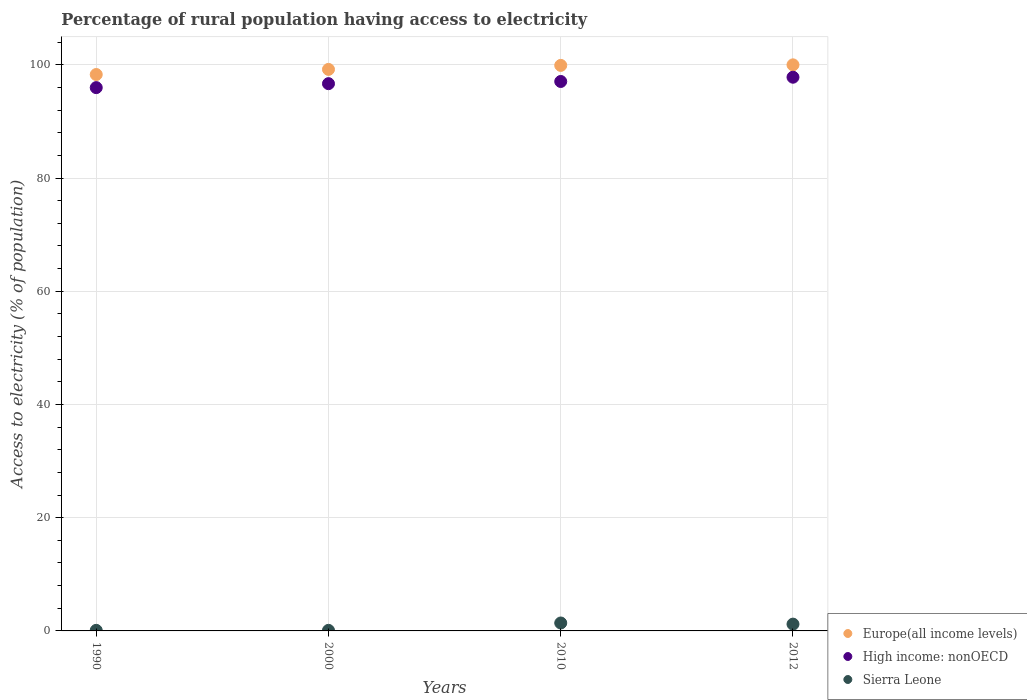How many different coloured dotlines are there?
Give a very brief answer. 3. Is the number of dotlines equal to the number of legend labels?
Make the answer very short. Yes. What is the percentage of rural population having access to electricity in Sierra Leone in 2000?
Provide a succinct answer. 0.1. Across all years, what is the maximum percentage of rural population having access to electricity in Europe(all income levels)?
Your answer should be very brief. 100. Across all years, what is the minimum percentage of rural population having access to electricity in Sierra Leone?
Give a very brief answer. 0.1. In which year was the percentage of rural population having access to electricity in High income: nonOECD maximum?
Offer a very short reply. 2012. What is the total percentage of rural population having access to electricity in Sierra Leone in the graph?
Provide a succinct answer. 2.8. What is the difference between the percentage of rural population having access to electricity in High income: nonOECD in 1990 and that in 2012?
Your response must be concise. -1.84. What is the difference between the percentage of rural population having access to electricity in High income: nonOECD in 1990 and the percentage of rural population having access to electricity in Europe(all income levels) in 2012?
Ensure brevity in your answer.  -4.02. What is the average percentage of rural population having access to electricity in Sierra Leone per year?
Offer a very short reply. 0.7. In the year 1990, what is the difference between the percentage of rural population having access to electricity in Sierra Leone and percentage of rural population having access to electricity in High income: nonOECD?
Your response must be concise. -95.88. What is the ratio of the percentage of rural population having access to electricity in High income: nonOECD in 2000 to that in 2010?
Ensure brevity in your answer.  1. Is the percentage of rural population having access to electricity in High income: nonOECD in 2000 less than that in 2010?
Keep it short and to the point. Yes. What is the difference between the highest and the second highest percentage of rural population having access to electricity in Sierra Leone?
Your response must be concise. 0.2. What is the difference between the highest and the lowest percentage of rural population having access to electricity in Europe(all income levels)?
Give a very brief answer. 1.71. In how many years, is the percentage of rural population having access to electricity in Sierra Leone greater than the average percentage of rural population having access to electricity in Sierra Leone taken over all years?
Offer a very short reply. 2. Is the sum of the percentage of rural population having access to electricity in High income: nonOECD in 2000 and 2012 greater than the maximum percentage of rural population having access to electricity in Sierra Leone across all years?
Make the answer very short. Yes. Is the percentage of rural population having access to electricity in Europe(all income levels) strictly less than the percentage of rural population having access to electricity in Sierra Leone over the years?
Your response must be concise. No. What is the difference between two consecutive major ticks on the Y-axis?
Your response must be concise. 20. Are the values on the major ticks of Y-axis written in scientific E-notation?
Provide a short and direct response. No. Does the graph contain any zero values?
Provide a succinct answer. No. Does the graph contain grids?
Offer a very short reply. Yes. What is the title of the graph?
Provide a short and direct response. Percentage of rural population having access to electricity. Does "High income" appear as one of the legend labels in the graph?
Keep it short and to the point. No. What is the label or title of the Y-axis?
Offer a terse response. Access to electricity (% of population). What is the Access to electricity (% of population) of Europe(all income levels) in 1990?
Make the answer very short. 98.29. What is the Access to electricity (% of population) in High income: nonOECD in 1990?
Your answer should be compact. 95.98. What is the Access to electricity (% of population) in Europe(all income levels) in 2000?
Your response must be concise. 99.2. What is the Access to electricity (% of population) in High income: nonOECD in 2000?
Your response must be concise. 96.68. What is the Access to electricity (% of population) in Europe(all income levels) in 2010?
Offer a very short reply. 99.9. What is the Access to electricity (% of population) of High income: nonOECD in 2010?
Keep it short and to the point. 97.06. What is the Access to electricity (% of population) of Europe(all income levels) in 2012?
Your answer should be very brief. 100. What is the Access to electricity (% of population) of High income: nonOECD in 2012?
Give a very brief answer. 97.82. What is the Access to electricity (% of population) of Sierra Leone in 2012?
Give a very brief answer. 1.2. Across all years, what is the maximum Access to electricity (% of population) in Europe(all income levels)?
Give a very brief answer. 100. Across all years, what is the maximum Access to electricity (% of population) in High income: nonOECD?
Give a very brief answer. 97.82. Across all years, what is the maximum Access to electricity (% of population) of Sierra Leone?
Provide a succinct answer. 1.4. Across all years, what is the minimum Access to electricity (% of population) in Europe(all income levels)?
Provide a succinct answer. 98.29. Across all years, what is the minimum Access to electricity (% of population) in High income: nonOECD?
Offer a very short reply. 95.98. Across all years, what is the minimum Access to electricity (% of population) of Sierra Leone?
Offer a terse response. 0.1. What is the total Access to electricity (% of population) in Europe(all income levels) in the graph?
Keep it short and to the point. 397.39. What is the total Access to electricity (% of population) of High income: nonOECD in the graph?
Give a very brief answer. 387.53. What is the difference between the Access to electricity (% of population) in Europe(all income levels) in 1990 and that in 2000?
Provide a succinct answer. -0.91. What is the difference between the Access to electricity (% of population) of High income: nonOECD in 1990 and that in 2000?
Offer a very short reply. -0.7. What is the difference between the Access to electricity (% of population) in Europe(all income levels) in 1990 and that in 2010?
Provide a succinct answer. -1.61. What is the difference between the Access to electricity (% of population) in High income: nonOECD in 1990 and that in 2010?
Provide a short and direct response. -1.08. What is the difference between the Access to electricity (% of population) in Sierra Leone in 1990 and that in 2010?
Keep it short and to the point. -1.3. What is the difference between the Access to electricity (% of population) of Europe(all income levels) in 1990 and that in 2012?
Offer a very short reply. -1.71. What is the difference between the Access to electricity (% of population) of High income: nonOECD in 1990 and that in 2012?
Make the answer very short. -1.84. What is the difference between the Access to electricity (% of population) of Sierra Leone in 1990 and that in 2012?
Make the answer very short. -1.1. What is the difference between the Access to electricity (% of population) in Europe(all income levels) in 2000 and that in 2010?
Offer a very short reply. -0.71. What is the difference between the Access to electricity (% of population) in High income: nonOECD in 2000 and that in 2010?
Keep it short and to the point. -0.39. What is the difference between the Access to electricity (% of population) in Europe(all income levels) in 2000 and that in 2012?
Your response must be concise. -0.8. What is the difference between the Access to electricity (% of population) of High income: nonOECD in 2000 and that in 2012?
Your response must be concise. -1.14. What is the difference between the Access to electricity (% of population) in Europe(all income levels) in 2010 and that in 2012?
Offer a very short reply. -0.1. What is the difference between the Access to electricity (% of population) in High income: nonOECD in 2010 and that in 2012?
Provide a short and direct response. -0.75. What is the difference between the Access to electricity (% of population) of Sierra Leone in 2010 and that in 2012?
Your response must be concise. 0.2. What is the difference between the Access to electricity (% of population) in Europe(all income levels) in 1990 and the Access to electricity (% of population) in High income: nonOECD in 2000?
Your answer should be very brief. 1.62. What is the difference between the Access to electricity (% of population) in Europe(all income levels) in 1990 and the Access to electricity (% of population) in Sierra Leone in 2000?
Give a very brief answer. 98.19. What is the difference between the Access to electricity (% of population) in High income: nonOECD in 1990 and the Access to electricity (% of population) in Sierra Leone in 2000?
Offer a terse response. 95.88. What is the difference between the Access to electricity (% of population) in Europe(all income levels) in 1990 and the Access to electricity (% of population) in High income: nonOECD in 2010?
Make the answer very short. 1.23. What is the difference between the Access to electricity (% of population) in Europe(all income levels) in 1990 and the Access to electricity (% of population) in Sierra Leone in 2010?
Provide a succinct answer. 96.89. What is the difference between the Access to electricity (% of population) of High income: nonOECD in 1990 and the Access to electricity (% of population) of Sierra Leone in 2010?
Your answer should be very brief. 94.58. What is the difference between the Access to electricity (% of population) of Europe(all income levels) in 1990 and the Access to electricity (% of population) of High income: nonOECD in 2012?
Keep it short and to the point. 0.48. What is the difference between the Access to electricity (% of population) in Europe(all income levels) in 1990 and the Access to electricity (% of population) in Sierra Leone in 2012?
Your response must be concise. 97.09. What is the difference between the Access to electricity (% of population) of High income: nonOECD in 1990 and the Access to electricity (% of population) of Sierra Leone in 2012?
Offer a terse response. 94.78. What is the difference between the Access to electricity (% of population) in Europe(all income levels) in 2000 and the Access to electricity (% of population) in High income: nonOECD in 2010?
Provide a succinct answer. 2.14. What is the difference between the Access to electricity (% of population) in Europe(all income levels) in 2000 and the Access to electricity (% of population) in Sierra Leone in 2010?
Your answer should be very brief. 97.8. What is the difference between the Access to electricity (% of population) of High income: nonOECD in 2000 and the Access to electricity (% of population) of Sierra Leone in 2010?
Provide a short and direct response. 95.28. What is the difference between the Access to electricity (% of population) of Europe(all income levels) in 2000 and the Access to electricity (% of population) of High income: nonOECD in 2012?
Make the answer very short. 1.38. What is the difference between the Access to electricity (% of population) in Europe(all income levels) in 2000 and the Access to electricity (% of population) in Sierra Leone in 2012?
Keep it short and to the point. 98. What is the difference between the Access to electricity (% of population) of High income: nonOECD in 2000 and the Access to electricity (% of population) of Sierra Leone in 2012?
Offer a very short reply. 95.48. What is the difference between the Access to electricity (% of population) in Europe(all income levels) in 2010 and the Access to electricity (% of population) in High income: nonOECD in 2012?
Ensure brevity in your answer.  2.09. What is the difference between the Access to electricity (% of population) of Europe(all income levels) in 2010 and the Access to electricity (% of population) of Sierra Leone in 2012?
Offer a terse response. 98.7. What is the difference between the Access to electricity (% of population) in High income: nonOECD in 2010 and the Access to electricity (% of population) in Sierra Leone in 2012?
Keep it short and to the point. 95.86. What is the average Access to electricity (% of population) in Europe(all income levels) per year?
Your answer should be compact. 99.35. What is the average Access to electricity (% of population) of High income: nonOECD per year?
Give a very brief answer. 96.88. In the year 1990, what is the difference between the Access to electricity (% of population) of Europe(all income levels) and Access to electricity (% of population) of High income: nonOECD?
Your response must be concise. 2.31. In the year 1990, what is the difference between the Access to electricity (% of population) in Europe(all income levels) and Access to electricity (% of population) in Sierra Leone?
Offer a very short reply. 98.19. In the year 1990, what is the difference between the Access to electricity (% of population) of High income: nonOECD and Access to electricity (% of population) of Sierra Leone?
Your response must be concise. 95.88. In the year 2000, what is the difference between the Access to electricity (% of population) in Europe(all income levels) and Access to electricity (% of population) in High income: nonOECD?
Offer a very short reply. 2.52. In the year 2000, what is the difference between the Access to electricity (% of population) of Europe(all income levels) and Access to electricity (% of population) of Sierra Leone?
Your answer should be compact. 99.1. In the year 2000, what is the difference between the Access to electricity (% of population) of High income: nonOECD and Access to electricity (% of population) of Sierra Leone?
Keep it short and to the point. 96.58. In the year 2010, what is the difference between the Access to electricity (% of population) in Europe(all income levels) and Access to electricity (% of population) in High income: nonOECD?
Offer a terse response. 2.84. In the year 2010, what is the difference between the Access to electricity (% of population) in Europe(all income levels) and Access to electricity (% of population) in Sierra Leone?
Offer a terse response. 98.5. In the year 2010, what is the difference between the Access to electricity (% of population) in High income: nonOECD and Access to electricity (% of population) in Sierra Leone?
Provide a succinct answer. 95.66. In the year 2012, what is the difference between the Access to electricity (% of population) of Europe(all income levels) and Access to electricity (% of population) of High income: nonOECD?
Provide a short and direct response. 2.18. In the year 2012, what is the difference between the Access to electricity (% of population) in Europe(all income levels) and Access to electricity (% of population) in Sierra Leone?
Offer a very short reply. 98.8. In the year 2012, what is the difference between the Access to electricity (% of population) in High income: nonOECD and Access to electricity (% of population) in Sierra Leone?
Offer a terse response. 96.62. What is the ratio of the Access to electricity (% of population) of Europe(all income levels) in 1990 to that in 2000?
Ensure brevity in your answer.  0.99. What is the ratio of the Access to electricity (% of population) of Europe(all income levels) in 1990 to that in 2010?
Your answer should be very brief. 0.98. What is the ratio of the Access to electricity (% of population) in Sierra Leone in 1990 to that in 2010?
Offer a very short reply. 0.07. What is the ratio of the Access to electricity (% of population) of Europe(all income levels) in 1990 to that in 2012?
Your response must be concise. 0.98. What is the ratio of the Access to electricity (% of population) of High income: nonOECD in 1990 to that in 2012?
Offer a terse response. 0.98. What is the ratio of the Access to electricity (% of population) of Sierra Leone in 1990 to that in 2012?
Your answer should be very brief. 0.08. What is the ratio of the Access to electricity (% of population) of Europe(all income levels) in 2000 to that in 2010?
Provide a short and direct response. 0.99. What is the ratio of the Access to electricity (% of population) in Sierra Leone in 2000 to that in 2010?
Offer a terse response. 0.07. What is the ratio of the Access to electricity (% of population) of High income: nonOECD in 2000 to that in 2012?
Your answer should be compact. 0.99. What is the ratio of the Access to electricity (% of population) in Sierra Leone in 2000 to that in 2012?
Your answer should be very brief. 0.08. What is the difference between the highest and the second highest Access to electricity (% of population) of Europe(all income levels)?
Your answer should be compact. 0.1. What is the difference between the highest and the second highest Access to electricity (% of population) in High income: nonOECD?
Provide a short and direct response. 0.75. What is the difference between the highest and the lowest Access to electricity (% of population) in Europe(all income levels)?
Provide a short and direct response. 1.71. What is the difference between the highest and the lowest Access to electricity (% of population) in High income: nonOECD?
Make the answer very short. 1.84. 